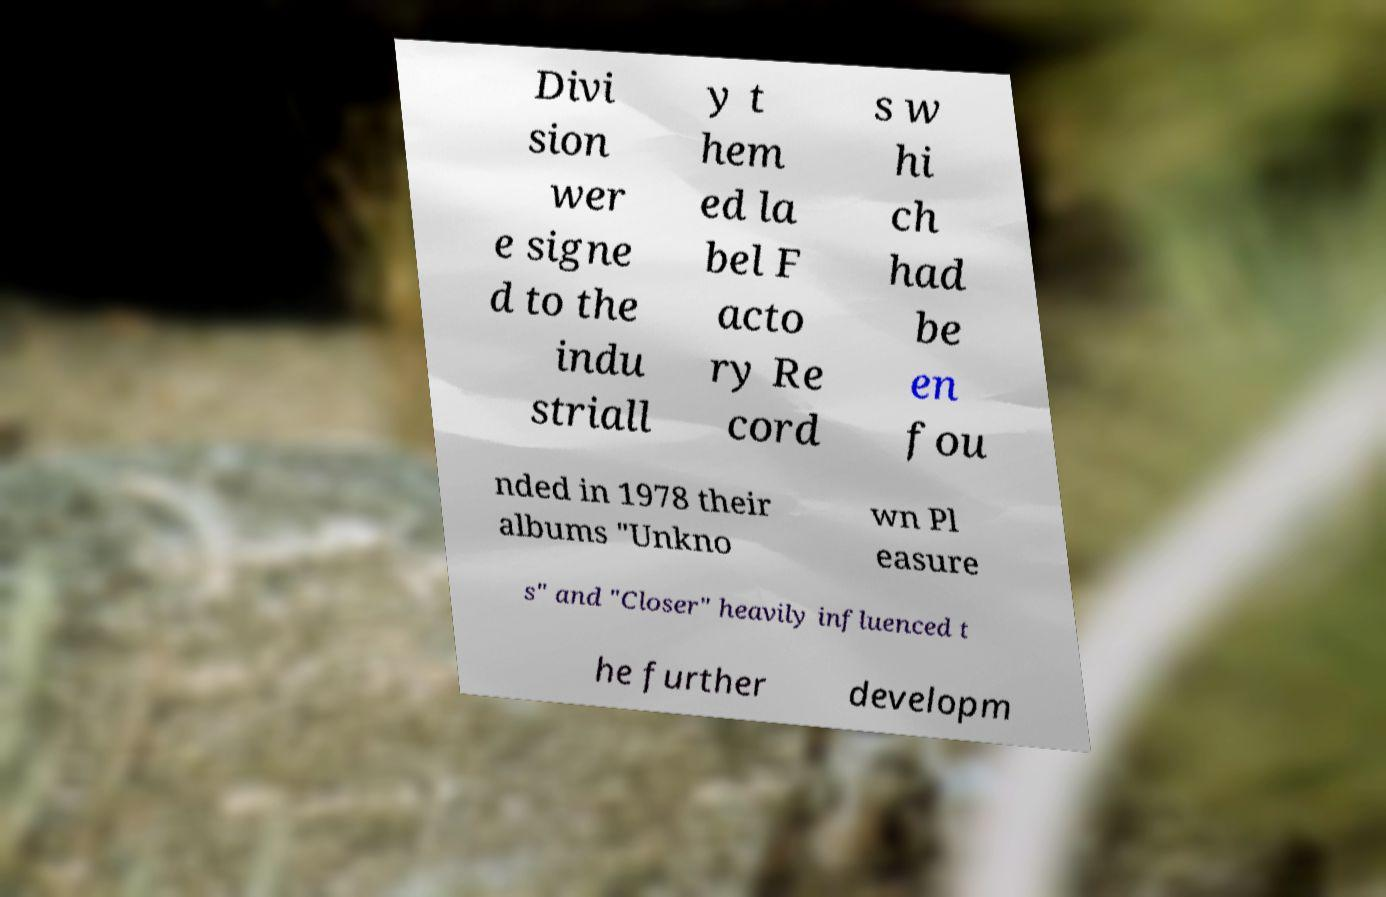Could you extract and type out the text from this image? Divi sion wer e signe d to the indu striall y t hem ed la bel F acto ry Re cord s w hi ch had be en fou nded in 1978 their albums "Unkno wn Pl easure s" and "Closer" heavily influenced t he further developm 